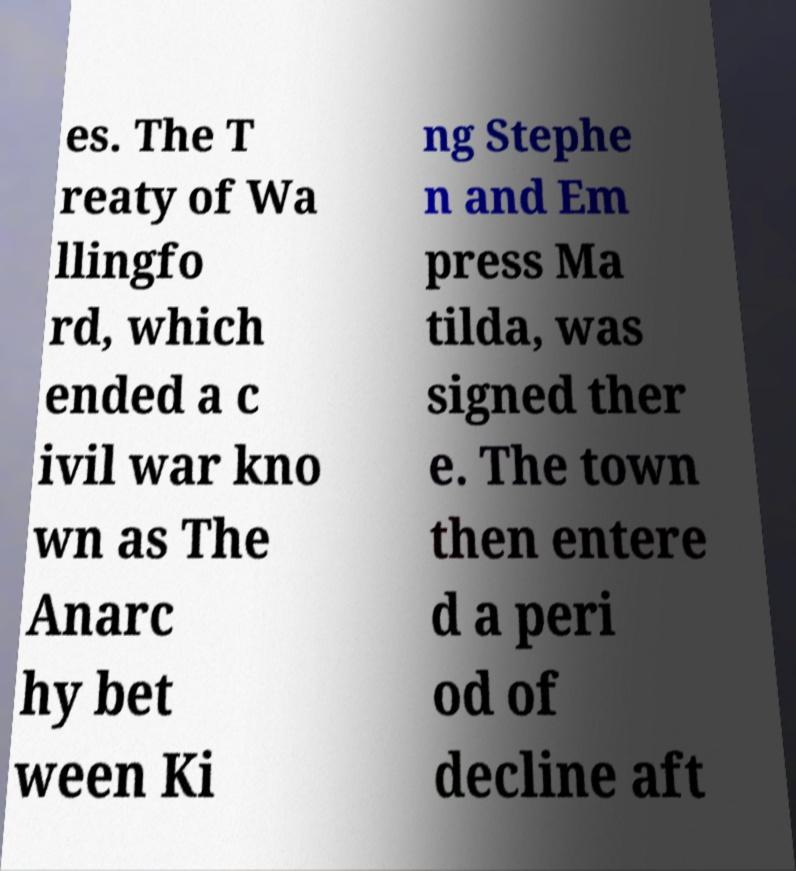Can you accurately transcribe the text from the provided image for me? es. The T reaty of Wa llingfo rd, which ended a c ivil war kno wn as The Anarc hy bet ween Ki ng Stephe n and Em press Ma tilda, was signed ther e. The town then entere d a peri od of decline aft 